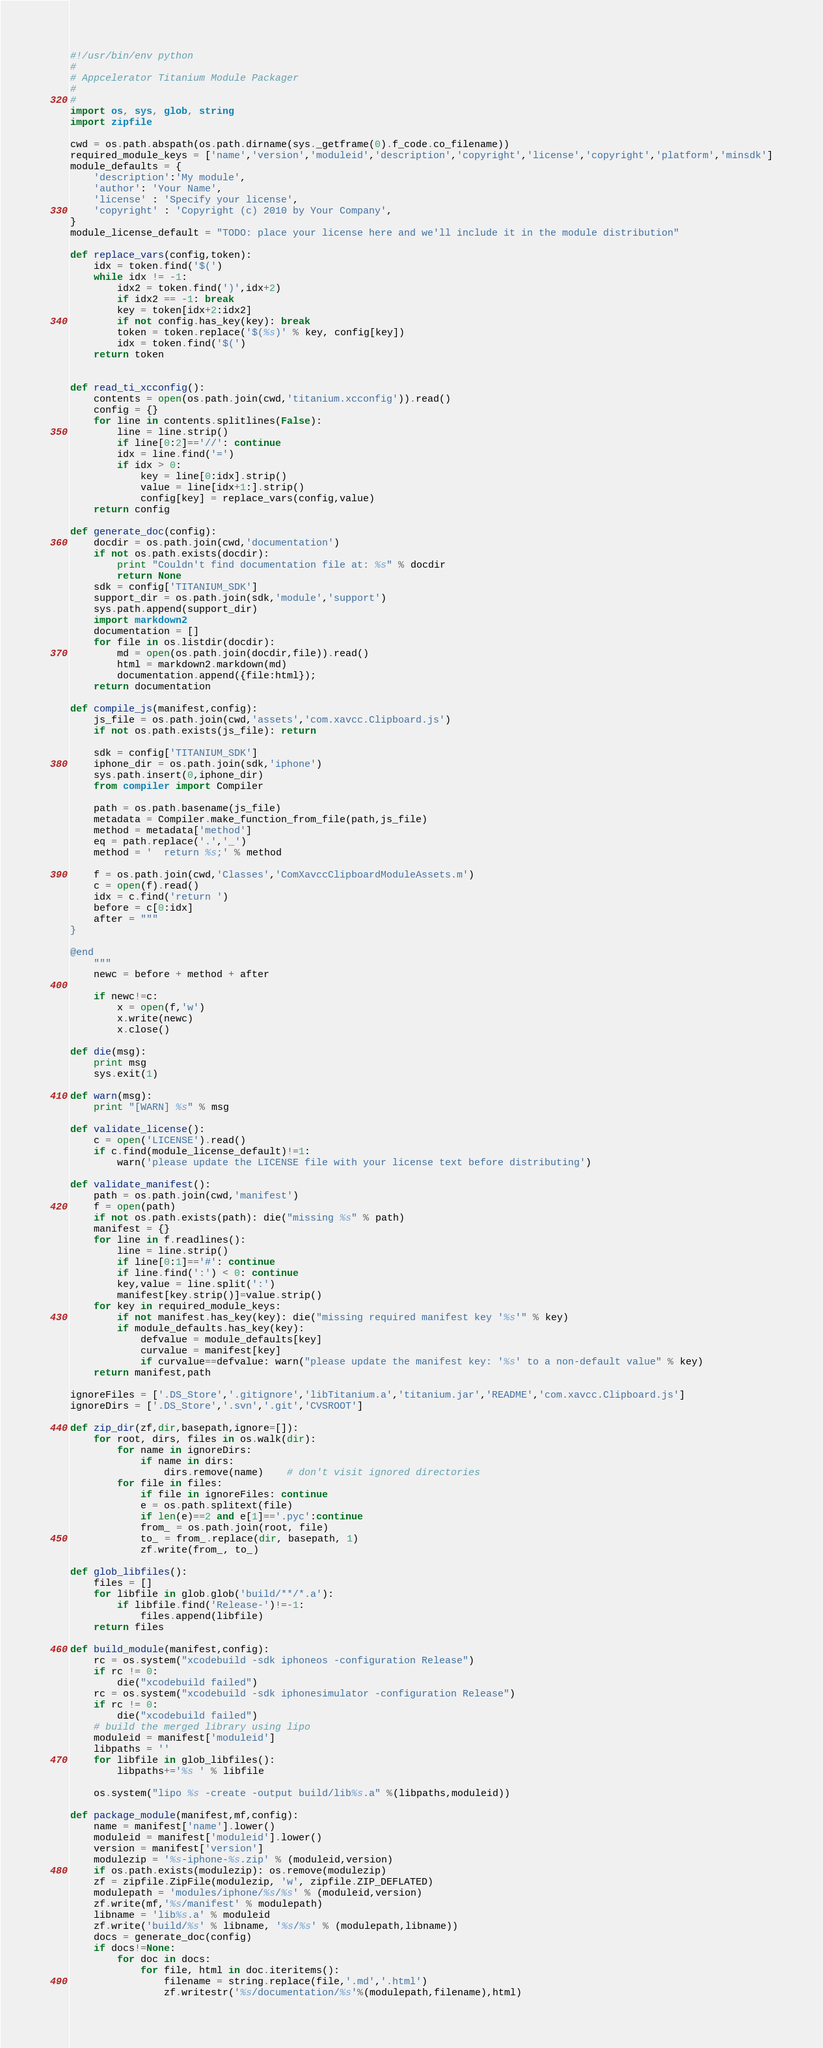<code> <loc_0><loc_0><loc_500><loc_500><_Python_>#!/usr/bin/env python
#
# Appcelerator Titanium Module Packager
#
#
import os, sys, glob, string
import zipfile

cwd = os.path.abspath(os.path.dirname(sys._getframe(0).f_code.co_filename))
required_module_keys = ['name','version','moduleid','description','copyright','license','copyright','platform','minsdk']
module_defaults = {
	'description':'My module',
	'author': 'Your Name',
	'license' : 'Specify your license',
	'copyright' : 'Copyright (c) 2010 by Your Company',
}
module_license_default = "TODO: place your license here and we'll include it in the module distribution"

def replace_vars(config,token):
	idx = token.find('$(')
	while idx != -1:
		idx2 = token.find(')',idx+2)
		if idx2 == -1: break
		key = token[idx+2:idx2]
		if not config.has_key(key): break
		token = token.replace('$(%s)' % key, config[key])
		idx = token.find('$(')
	return token
		
		
def read_ti_xcconfig():
	contents = open(os.path.join(cwd,'titanium.xcconfig')).read()
	config = {}
	for line in contents.splitlines(False):
		line = line.strip()
		if line[0:2]=='//': continue
		idx = line.find('=')
		if idx > 0:
			key = line[0:idx].strip()
			value = line[idx+1:].strip()
			config[key] = replace_vars(config,value)
	return config

def generate_doc(config):
	docdir = os.path.join(cwd,'documentation')
	if not os.path.exists(docdir):
		print "Couldn't find documentation file at: %s" % docdir
		return None
	sdk = config['TITANIUM_SDK']
	support_dir = os.path.join(sdk,'module','support')
	sys.path.append(support_dir)
	import markdown2
	documentation = []
	for file in os.listdir(docdir):
		md = open(os.path.join(docdir,file)).read()
		html = markdown2.markdown(md)
		documentation.append({file:html});
	return documentation

def compile_js(manifest,config):
	js_file = os.path.join(cwd,'assets','com.xavcc.Clipboard.js')
	if not os.path.exists(js_file): return
	
	sdk = config['TITANIUM_SDK']
	iphone_dir = os.path.join(sdk,'iphone')
	sys.path.insert(0,iphone_dir)
	from compiler import Compiler
	
	path = os.path.basename(js_file)
	metadata = Compiler.make_function_from_file(path,js_file)
	method = metadata['method']
	eq = path.replace('.','_')
	method = '  return %s;' % method
	
	f = os.path.join(cwd,'Classes','ComXavccClipboardModuleAssets.m')
	c = open(f).read()
	idx = c.find('return ')
	before = c[0:idx]
	after = """
}

@end
	"""
	newc = before + method + after
	
	if newc!=c:
		x = open(f,'w')
		x.write(newc)
		x.close()
		
def die(msg):
	print msg
	sys.exit(1)

def warn(msg):
	print "[WARN] %s" % msg	

def validate_license():
	c = open('LICENSE').read()
	if c.find(module_license_default)!=1:
		warn('please update the LICENSE file with your license text before distributing')
			
def validate_manifest():
	path = os.path.join(cwd,'manifest')
	f = open(path)
	if not os.path.exists(path): die("missing %s" % path)
	manifest = {}
	for line in f.readlines():
		line = line.strip()
		if line[0:1]=='#': continue
		if line.find(':') < 0: continue
		key,value = line.split(':')
		manifest[key.strip()]=value.strip()
	for key in required_module_keys:
		if not manifest.has_key(key): die("missing required manifest key '%s'" % key)	
		if module_defaults.has_key(key):
			defvalue = module_defaults[key]
			curvalue = manifest[key]
			if curvalue==defvalue: warn("please update the manifest key: '%s' to a non-default value" % key)
	return manifest,path

ignoreFiles = ['.DS_Store','.gitignore','libTitanium.a','titanium.jar','README','com.xavcc.Clipboard.js']
ignoreDirs = ['.DS_Store','.svn','.git','CVSROOT']

def zip_dir(zf,dir,basepath,ignore=[]):
	for root, dirs, files in os.walk(dir):
		for name in ignoreDirs:
			if name in dirs:
				dirs.remove(name)	# don't visit ignored directories			  
		for file in files:
			if file in ignoreFiles: continue
			e = os.path.splitext(file)
			if len(e)==2 and e[1]=='.pyc':continue
			from_ = os.path.join(root, file)	
			to_ = from_.replace(dir, basepath, 1)
			zf.write(from_, to_)

def glob_libfiles():
	files = []
	for libfile in glob.glob('build/**/*.a'):
		if libfile.find('Release-')!=-1:
			files.append(libfile)
	return files

def build_module(manifest,config):
	rc = os.system("xcodebuild -sdk iphoneos -configuration Release")
	if rc != 0:
		die("xcodebuild failed")
	rc = os.system("xcodebuild -sdk iphonesimulator -configuration Release")
	if rc != 0:
		die("xcodebuild failed")
    # build the merged library using lipo
	moduleid = manifest['moduleid']
	libpaths = ''
	for libfile in glob_libfiles():
		libpaths+='%s ' % libfile
		
	os.system("lipo %s -create -output build/lib%s.a" %(libpaths,moduleid))
	
def package_module(manifest,mf,config):
	name = manifest['name'].lower()
	moduleid = manifest['moduleid'].lower()
	version = manifest['version']
	modulezip = '%s-iphone-%s.zip' % (moduleid,version)
	if os.path.exists(modulezip): os.remove(modulezip)
	zf = zipfile.ZipFile(modulezip, 'w', zipfile.ZIP_DEFLATED)
	modulepath = 'modules/iphone/%s/%s' % (moduleid,version)
	zf.write(mf,'%s/manifest' % modulepath)
	libname = 'lib%s.a' % moduleid
	zf.write('build/%s' % libname, '%s/%s' % (modulepath,libname))
	docs = generate_doc(config)
	if docs!=None:
		for doc in docs:
			for file, html in doc.iteritems():
				filename = string.replace(file,'.md','.html')
				zf.writestr('%s/documentation/%s'%(modulepath,filename),html)</code> 